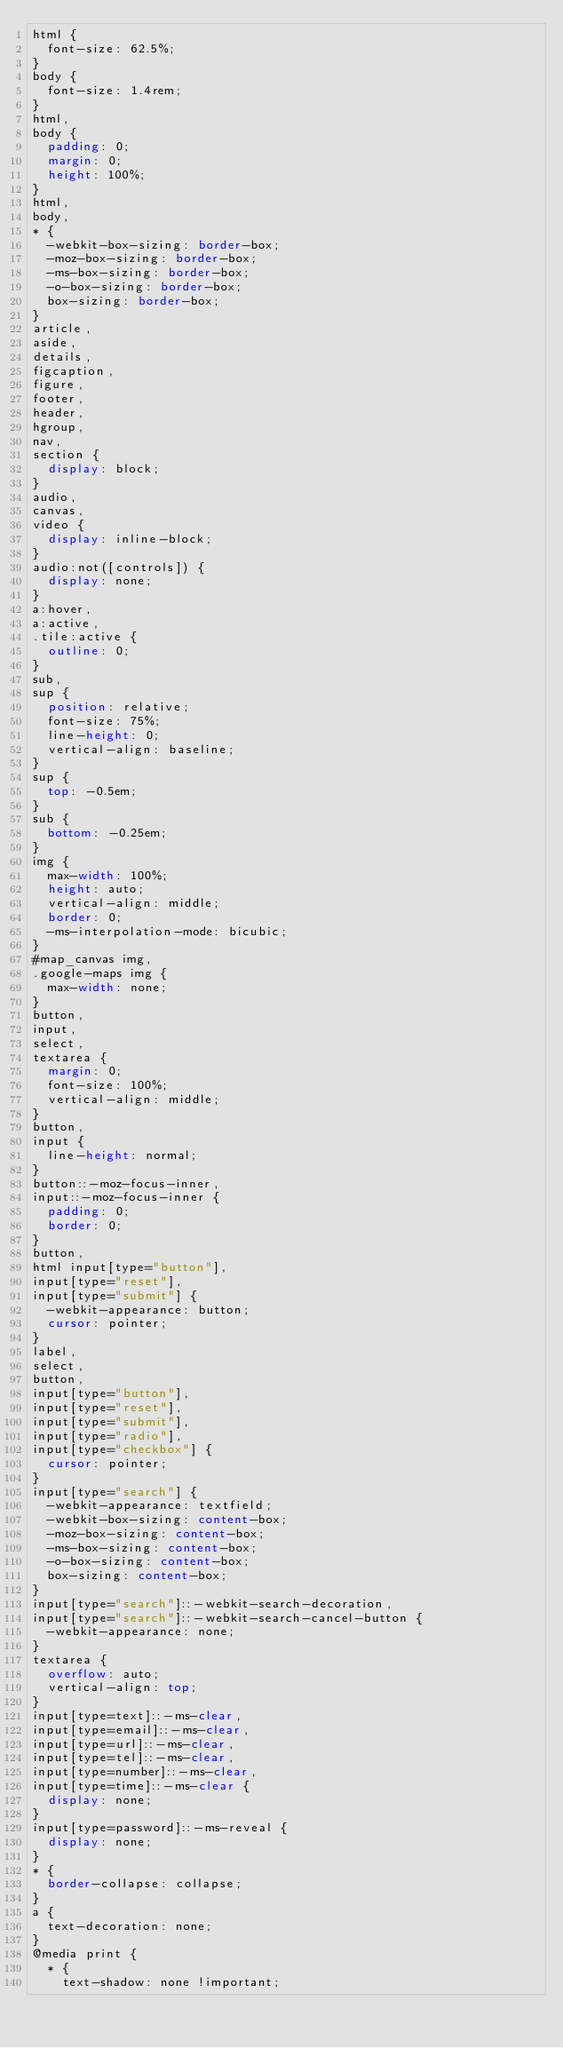Convert code to text. <code><loc_0><loc_0><loc_500><loc_500><_CSS_>html {
  font-size: 62.5%;
}
body {
  font-size: 1.4rem;
}
html,
body {
  padding: 0;
  margin: 0;
  height: 100%;
}
html,
body,
* {
  -webkit-box-sizing: border-box;
  -moz-box-sizing: border-box;
  -ms-box-sizing: border-box;
  -o-box-sizing: border-box;
  box-sizing: border-box;
}
article,
aside,
details,
figcaption,
figure,
footer,
header,
hgroup,
nav,
section {
  display: block;
}
audio,
canvas,
video {
  display: inline-block;
}
audio:not([controls]) {
  display: none;
}
a:hover,
a:active,
.tile:active {
  outline: 0;
}
sub,
sup {
  position: relative;
  font-size: 75%;
  line-height: 0;
  vertical-align: baseline;
}
sup {
  top: -0.5em;
}
sub {
  bottom: -0.25em;
}
img {
  max-width: 100%;
  height: auto;
  vertical-align: middle;
  border: 0;
  -ms-interpolation-mode: bicubic;
}
#map_canvas img,
.google-maps img {
  max-width: none;
}
button,
input,
select,
textarea {
  margin: 0;
  font-size: 100%;
  vertical-align: middle;
}
button,
input {
  line-height: normal;
}
button::-moz-focus-inner,
input::-moz-focus-inner {
  padding: 0;
  border: 0;
}
button,
html input[type="button"],
input[type="reset"],
input[type="submit"] {
  -webkit-appearance: button;
  cursor: pointer;
}
label,
select,
button,
input[type="button"],
input[type="reset"],
input[type="submit"],
input[type="radio"],
input[type="checkbox"] {
  cursor: pointer;
}
input[type="search"] {
  -webkit-appearance: textfield;
  -webkit-box-sizing: content-box;
  -moz-box-sizing: content-box;
  -ms-box-sizing: content-box;
  -o-box-sizing: content-box;
  box-sizing: content-box;
}
input[type="search"]::-webkit-search-decoration,
input[type="search"]::-webkit-search-cancel-button {
  -webkit-appearance: none;
}
textarea {
  overflow: auto;
  vertical-align: top;
}
input[type=text]::-ms-clear,
input[type=email]::-ms-clear,
input[type=url]::-ms-clear,
input[type=tel]::-ms-clear,
input[type=number]::-ms-clear,
input[type=time]::-ms-clear {
  display: none;
}
input[type=password]::-ms-reveal {
  display: none;
}
* {
  border-collapse: collapse;
}
a {
  text-decoration: none;
}
@media print {
  * {
    text-shadow: none !important;</code> 